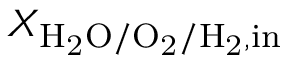<formula> <loc_0><loc_0><loc_500><loc_500>X _ { H _ { 2 } O / O _ { 2 } / H _ { 2 } , i n }</formula> 